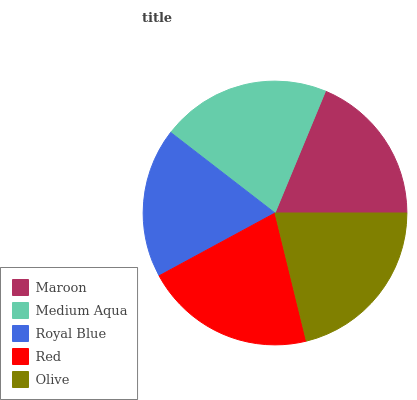Is Royal Blue the minimum?
Answer yes or no. Yes. Is Olive the maximum?
Answer yes or no. Yes. Is Medium Aqua the minimum?
Answer yes or no. No. Is Medium Aqua the maximum?
Answer yes or no. No. Is Medium Aqua greater than Maroon?
Answer yes or no. Yes. Is Maroon less than Medium Aqua?
Answer yes or no. Yes. Is Maroon greater than Medium Aqua?
Answer yes or no. No. Is Medium Aqua less than Maroon?
Answer yes or no. No. Is Medium Aqua the high median?
Answer yes or no. Yes. Is Medium Aqua the low median?
Answer yes or no. Yes. Is Maroon the high median?
Answer yes or no. No. Is Maroon the low median?
Answer yes or no. No. 